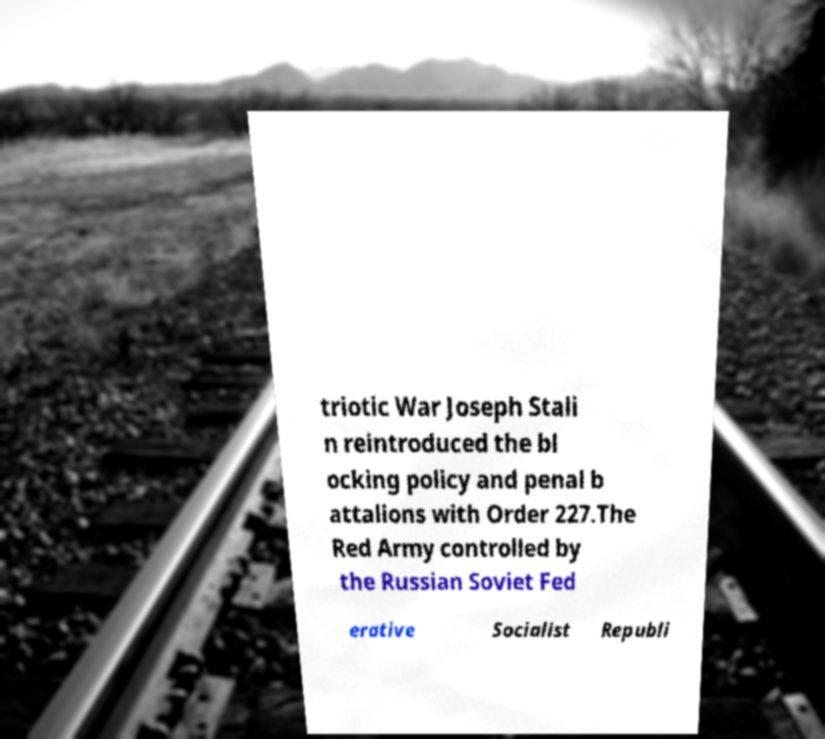Can you read and provide the text displayed in the image?This photo seems to have some interesting text. Can you extract and type it out for me? triotic War Joseph Stali n reintroduced the bl ocking policy and penal b attalions with Order 227.The Red Army controlled by the Russian Soviet Fed erative Socialist Republi 